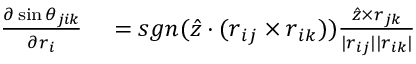<formula> <loc_0><loc_0><loc_500><loc_500>\begin{array} { r l } { \frac { \partial \sin \theta _ { j i k } } { \partial r _ { i } } } & = s g n ( \hat { z } \cdot ( r _ { i j } \times r _ { i k } ) ) \frac { \hat { z } \times r _ { j k } } { | r _ { i j } | | r _ { i k } | } } \end{array}</formula> 